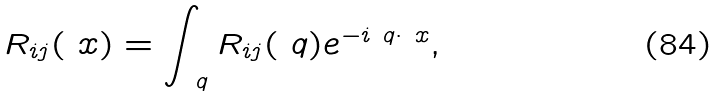Convert formula to latex. <formula><loc_0><loc_0><loc_500><loc_500>R _ { i j } ( \ x ) = \int _ { \ q } R _ { i j } ( \ q ) e ^ { - i \ q \cdot \ x } ,</formula> 